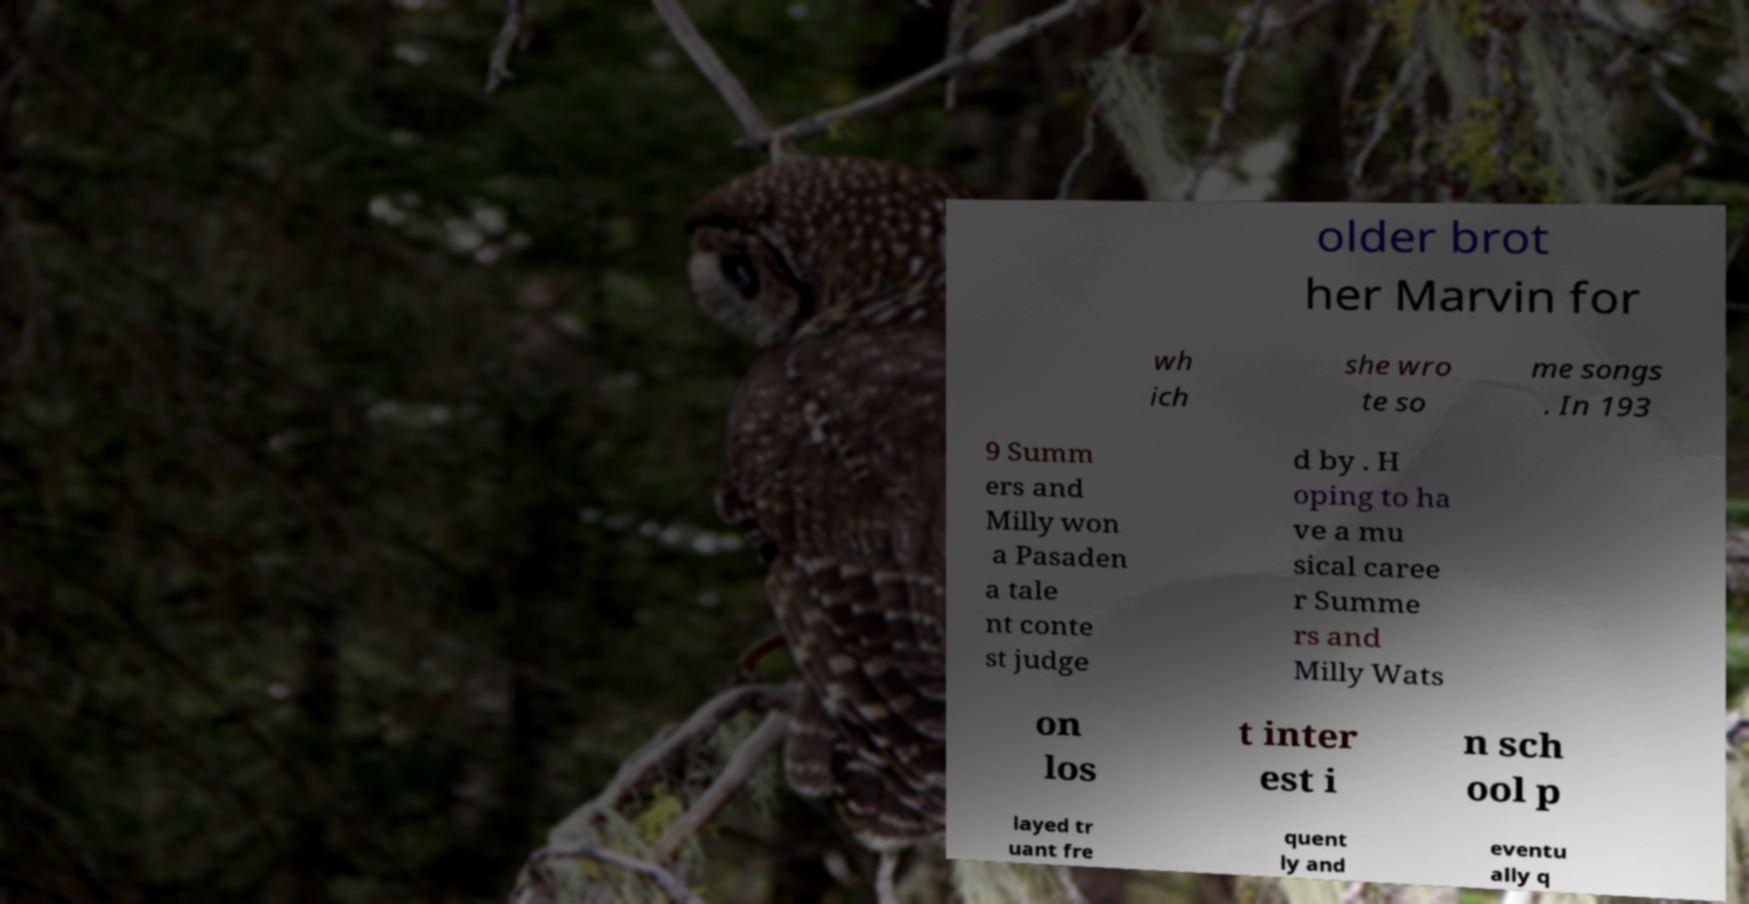For documentation purposes, I need the text within this image transcribed. Could you provide that? older brot her Marvin for wh ich she wro te so me songs . In 193 9 Summ ers and Milly won a Pasaden a tale nt conte st judge d by . H oping to ha ve a mu sical caree r Summe rs and Milly Wats on los t inter est i n sch ool p layed tr uant fre quent ly and eventu ally q 